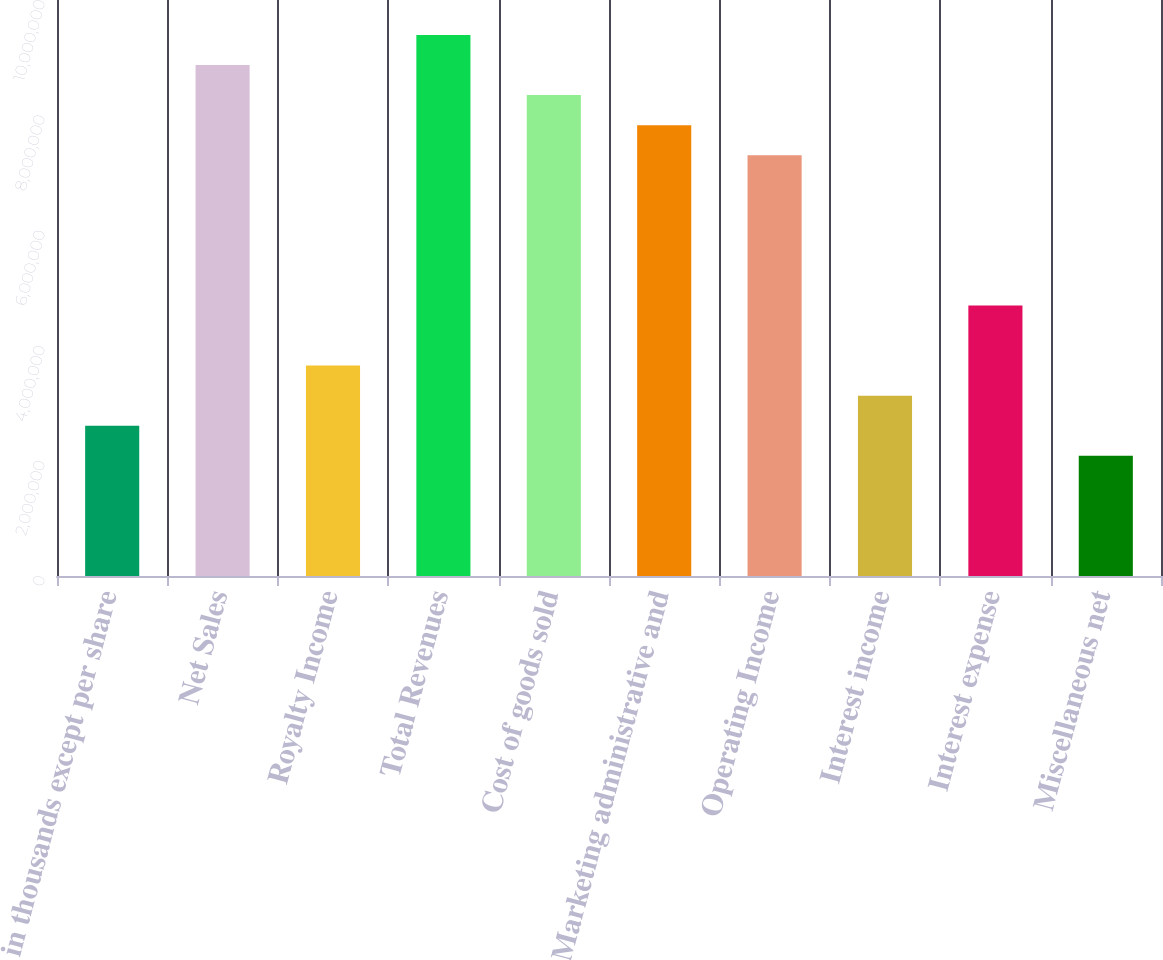<chart> <loc_0><loc_0><loc_500><loc_500><bar_chart><fcel>in thousands except per share<fcel>Net Sales<fcel>Royalty Income<fcel>Total Revenues<fcel>Cost of goods sold<fcel>Marketing administrative and<fcel>Operating Income<fcel>Interest income<fcel>Interest expense<fcel>Miscellaneous net<nl><fcel>2.60903e+06<fcel>8.87071e+06<fcel>3.65265e+06<fcel>9.39252e+06<fcel>8.34891e+06<fcel>7.8271e+06<fcel>7.30529e+06<fcel>3.13084e+06<fcel>4.69626e+06<fcel>2.08723e+06<nl></chart> 